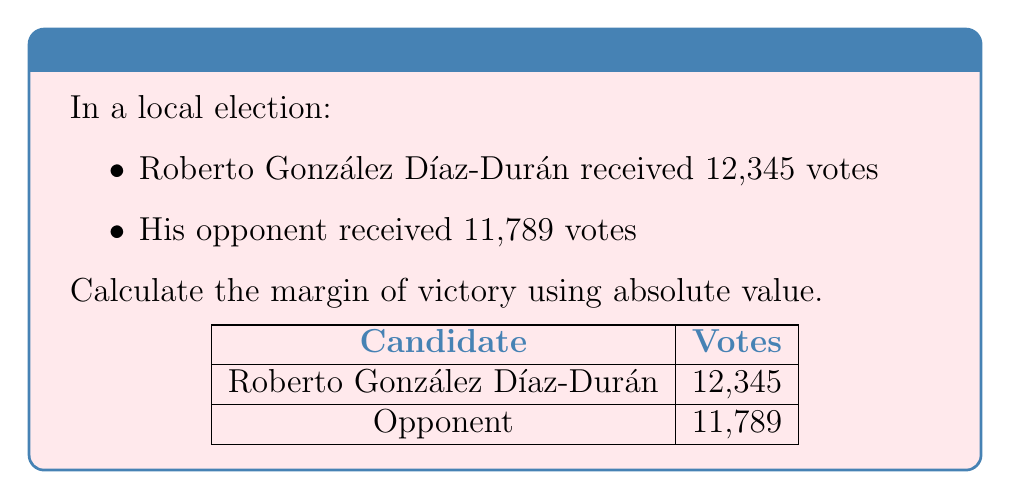What is the answer to this math problem? To determine the margin of victory using absolute value, we need to follow these steps:

1. Calculate the difference between the votes received by Roberto González Díaz-Durán and his opponent:
   $12,345 - 11,789 = 556$

2. Take the absolute value of this difference:
   $|556| = 556$

The absolute value ensures that we always get a positive number, regardless of which candidate received more votes. In this case, since Roberto González Díaz-Durán received more votes, the difference was already positive.

The margin of victory is therefore 556 votes.
Answer: 556 